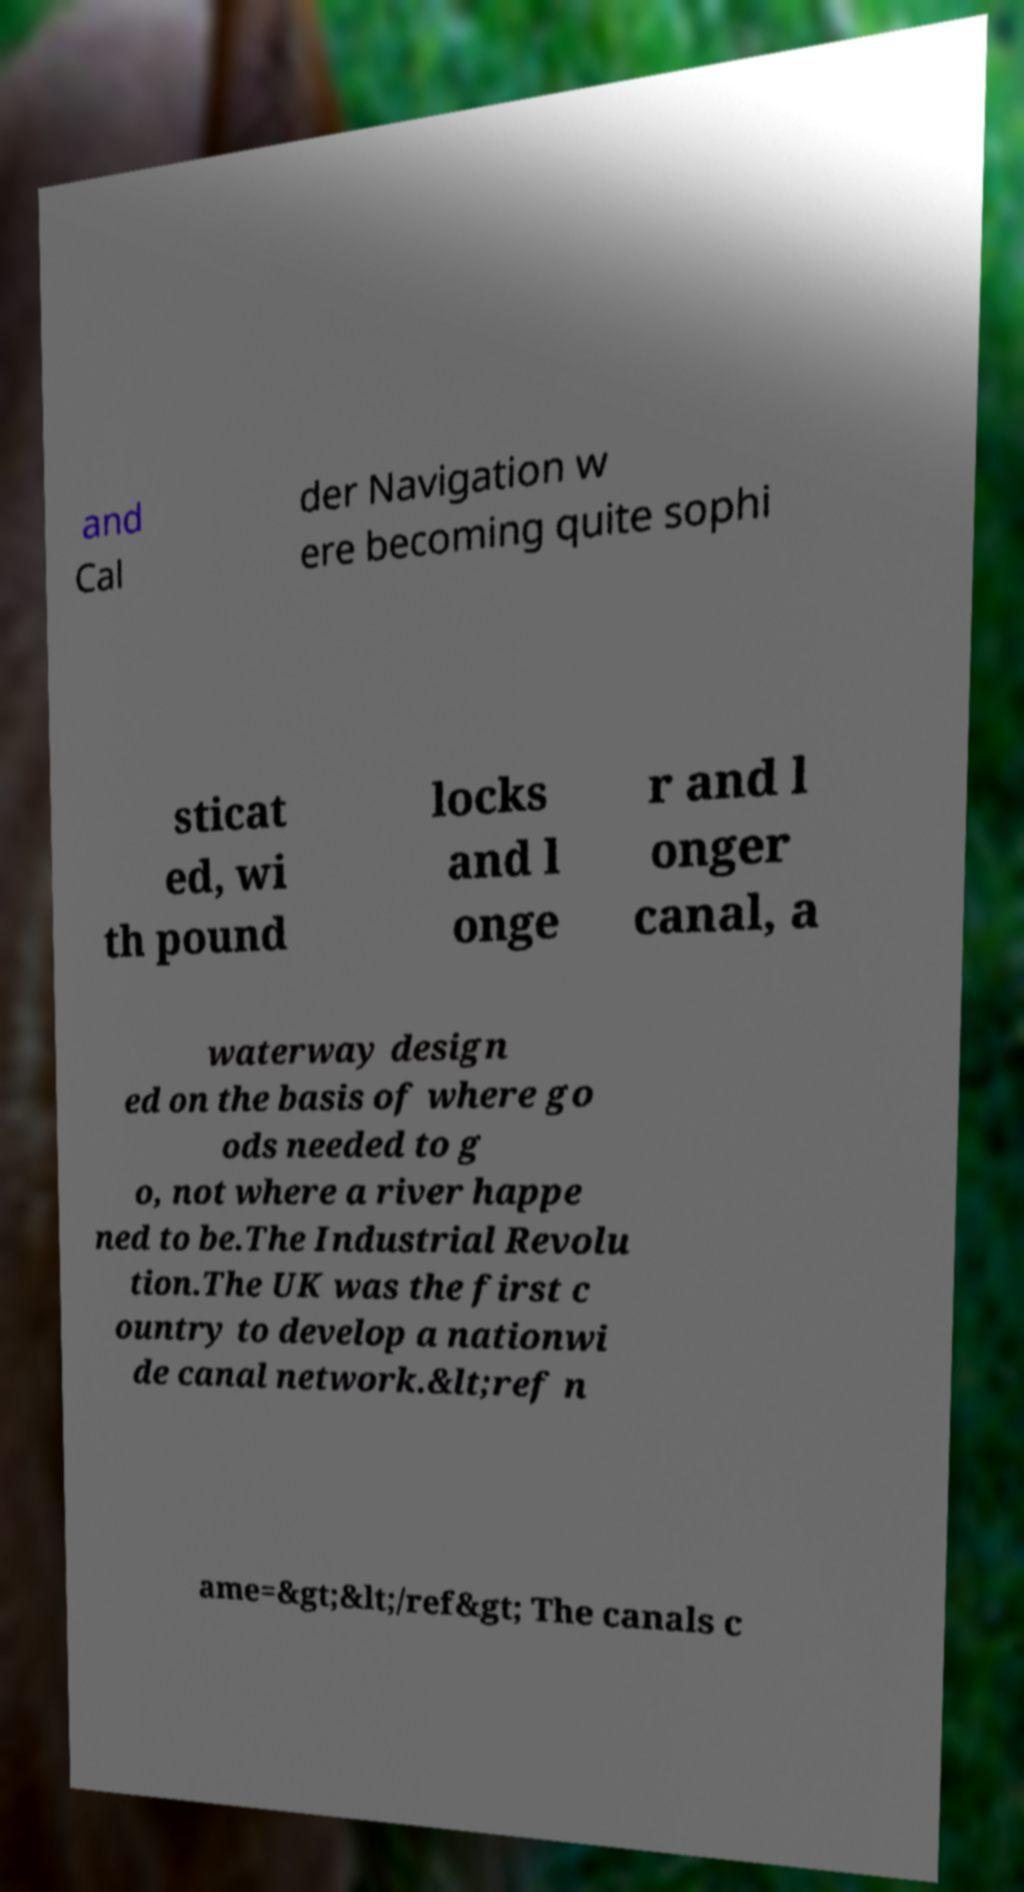Can you accurately transcribe the text from the provided image for me? and Cal der Navigation w ere becoming quite sophi sticat ed, wi th pound locks and l onge r and l onger canal, a waterway design ed on the basis of where go ods needed to g o, not where a river happe ned to be.The Industrial Revolu tion.The UK was the first c ountry to develop a nationwi de canal network.&lt;ref n ame=&gt;&lt;/ref&gt; The canals c 